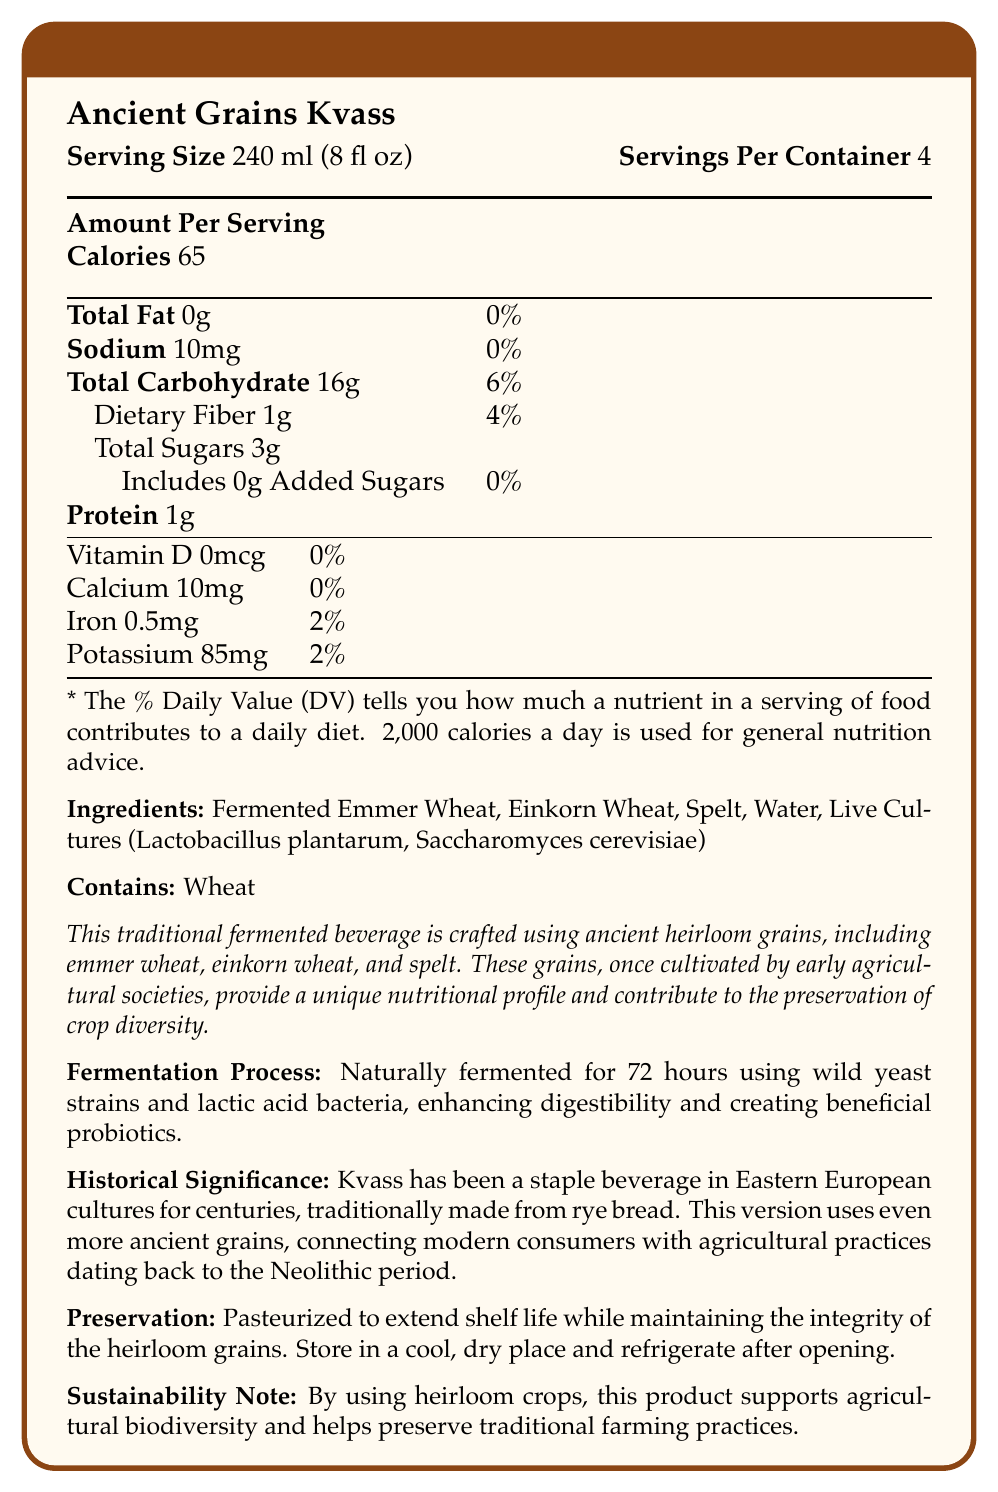what is the serving size? The serving size is clearly listed as "Serving Size 240 ml (8 fl oz)" at the beginning of the document.
Answer: 240 ml (8 fl oz) what grains are used in the Ancient Grains Kvass? The document lists "Fermented Emmer Wheat, Einkorn Wheat, Spelt" under the ingredients.
Answer: Emmer Wheat, Einkorn Wheat, Spelt how many servings are in a container? The document mentions "Servings Per Container 4" right next to the serving size.
Answer: 4 how many calories are there per serving? The document specifies "Calories 65" under the Amount Per Serving section.
Answer: 65 what is the amount of dietary fiber per serving? Dietary Fiber is listed as "1g" under the Total Carbohydrate section in the Amount Per Serving table.
Answer: 1g what does the document identify as the allergens? The allergen warning states "Contains: Wheat".
Answer: Wheat does the beverage contain any added sugars? The document states "Includes 0g Added Sugars."
Answer: No is the beverage pasteurized? The Preservation section states "Pasteurized to extend shelf life."
Answer: Yes which microorganism is mentioned as a live culture? A. Lactobacillus plantarum B. Saccharomyces cerevisiae C. Both D. Neither The document lists "Live Cultures (Lactobacillus plantarum, Saccharomyces cerevisiae)" under the ingredients.
Answer: C what is the total carbohydrate daily value percentage? 1. 4% 2. 6% 3. 10% The document lists "Total Carbohydrate 16g" with a daily value percentage of "6%".
Answer: 2 does the beverage contain any vitamin D? The document specifies "Vitamin D 0mcg" with a daily value of "0%".
Answer: No summarize the main idea of the document The document offers comprehensive information on Ancient Grains Kvass, including its nutritional content, ingredients, fermentation process, historical importance, and sustainability benefits.
Answer: The document provides detailed nutritional information about Ancient Grains Kvass, a traditional fermented beverage made from heirloom grains like Emmer Wheat, Einkorn Wheat, and Spelt. It includes serving size, calories, and other nutritional content, along with historical significance, fermentation process, preservation method, and sustainability contributions. what does the fermentation process involve? The Fermentation Process section states "Naturally fermented for 72 hours using wild yeast strains and lactic acid bacteria."
Answer: Naturally fermented for 72 hours using wild yeast strains and lactic acid bacteria how much potassium is in one serving? Potassium content is listed as "85 mg" with a daily value of "2%".
Answer: 85 mg what is the connection of Ancient Grains Kvass to early agricultural societies? The Product Description section highlights that "These grains, once cultivated by early agricultural societies, provide a unique nutritional profile and contribute to the preservation of crop diversity."
Answer: The grains used, such as emmer wheat and einkorn wheat, were once cultivated by early agricultural societies, providing a unique nutritional profile and preserving crop diversity. was the beverage traditionally made from rye bread in Eastern European cultures? The Historical Significance section mentions "Kvass has been a staple beverage in Eastern European cultures for centuries, traditionally made from rye bread."
Answer: Yes where should the beverage be stored after opening? The Preservation section states "Store in a cool, dry place and refrigerate after opening."
Answer: Refrigerate does the document state the vitamin A content? The document does not mention Vitamin A under the nutritional content.
Answer: Not enough information 